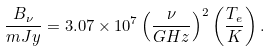Convert formula to latex. <formula><loc_0><loc_0><loc_500><loc_500>\frac { B _ { \nu } } { m J y } = 3 . 0 7 \times 1 0 ^ { 7 } \left ( \frac { \nu } { G H z } \right ) ^ { 2 } \left ( \frac { T _ { e } } { K } \right ) .</formula> 